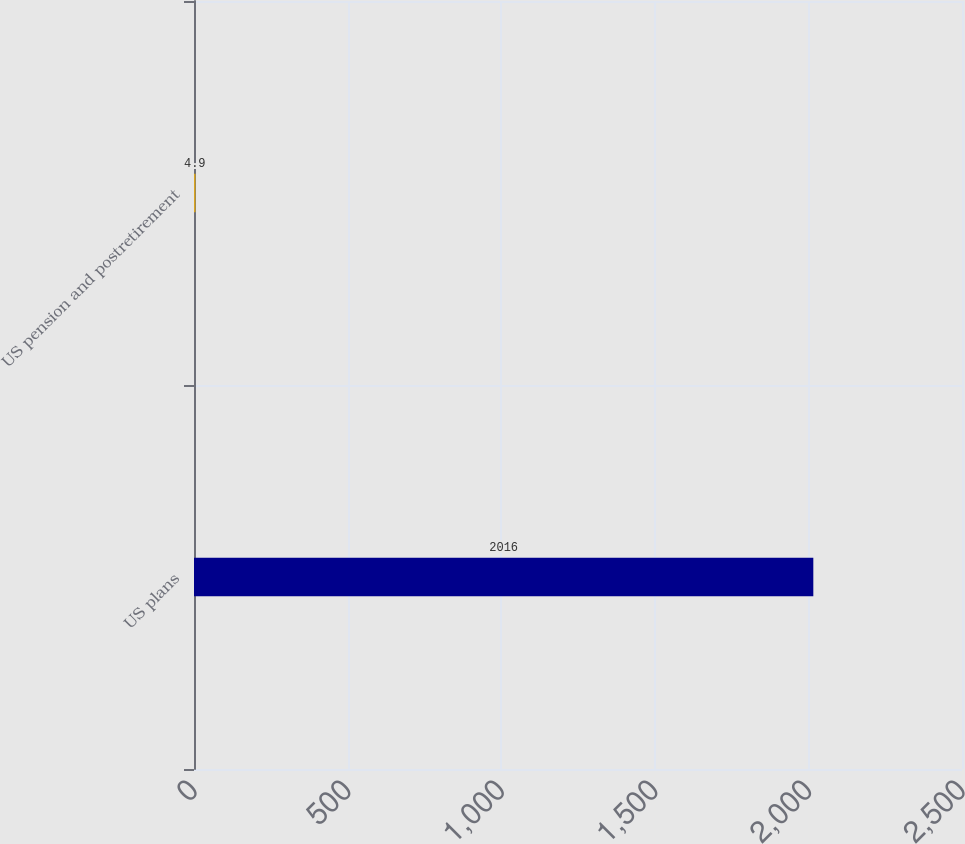Convert chart to OTSL. <chart><loc_0><loc_0><loc_500><loc_500><bar_chart><fcel>US plans<fcel>US pension and postretirement<nl><fcel>2016<fcel>4.9<nl></chart> 